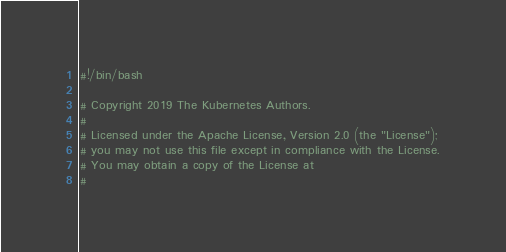Convert code to text. <code><loc_0><loc_0><loc_500><loc_500><_Bash_>#!/bin/bash

# Copyright 2019 The Kubernetes Authors.
#
# Licensed under the Apache License, Version 2.0 (the "License");
# you may not use this file except in compliance with the License.
# You may obtain a copy of the License at
#</code> 